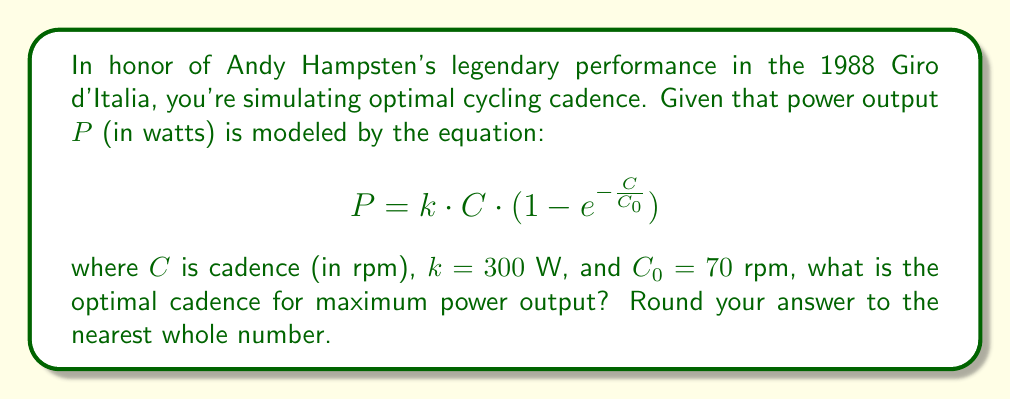Provide a solution to this math problem. To find the optimal cadence for maximum power output, we need to find the maximum of the given function. We can do this by taking the derivative of $P$ with respect to $C$ and setting it equal to zero.

1) First, let's take the derivative of $P$ with respect to $C$:

   $$\frac{dP}{dC} = k \cdot (1 - e^{-\frac{C}{C_0}}) + k \cdot C \cdot \frac{1}{C_0} \cdot e^{-\frac{C}{C_0}}$$

2) Now, set this equal to zero:

   $$k \cdot (1 - e^{-\frac{C}{C_0}}) + k \cdot C \cdot \frac{1}{C_0} \cdot e^{-\frac{C}{C_0}} = 0$$

3) Divide both sides by $k$ (since $k \neq 0$):

   $$1 - e^{-\frac{C}{C_0}} + \frac{C}{C_0} \cdot e^{-\frac{C}{C_0}} = 0$$

4) Rearrange:

   $$1 = e^{-\frac{C}{C_0}} \cdot (1 - \frac{C}{C_0})$$

5) Take the natural log of both sides:

   $$0 = -\frac{C}{C_0} + \ln(1 - \frac{C}{C_0})$$

6) This equation can't be solved analytically, so we need to use numerical methods. Using a calculator or computer, we can find that the solution is approximately:

   $$\frac{C}{C_0} \approx 0.7968$$

7) Multiply both sides by $C_0 = 70$ rpm:

   $$C \approx 0.7968 \cdot 70 \approx 55.776$$

8) Rounding to the nearest whole number:

   $$C \approx 56 \text{ rpm}$$

Therefore, the optimal cadence for maximum power output is approximately 56 rpm.
Answer: 56 rpm 